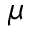Convert formula to latex. <formula><loc_0><loc_0><loc_500><loc_500>\mu</formula> 